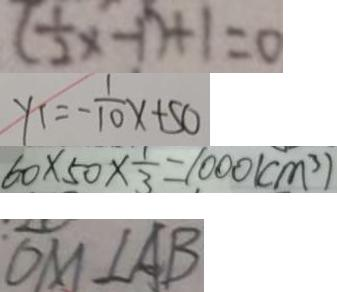Convert formula to latex. <formula><loc_0><loc_0><loc_500><loc_500>( \frac { 1 } { 2 } x - 1 ) + 1 = 0 
 y 1 = - \frac { 1 } { 1 0 } x + 5 0 
 6 0 \times 5 0 \times \frac { 1 } { 3 } = 1 0 0 0 ( c m ^ { 3 } ) 
 O M \bot A B</formula> 